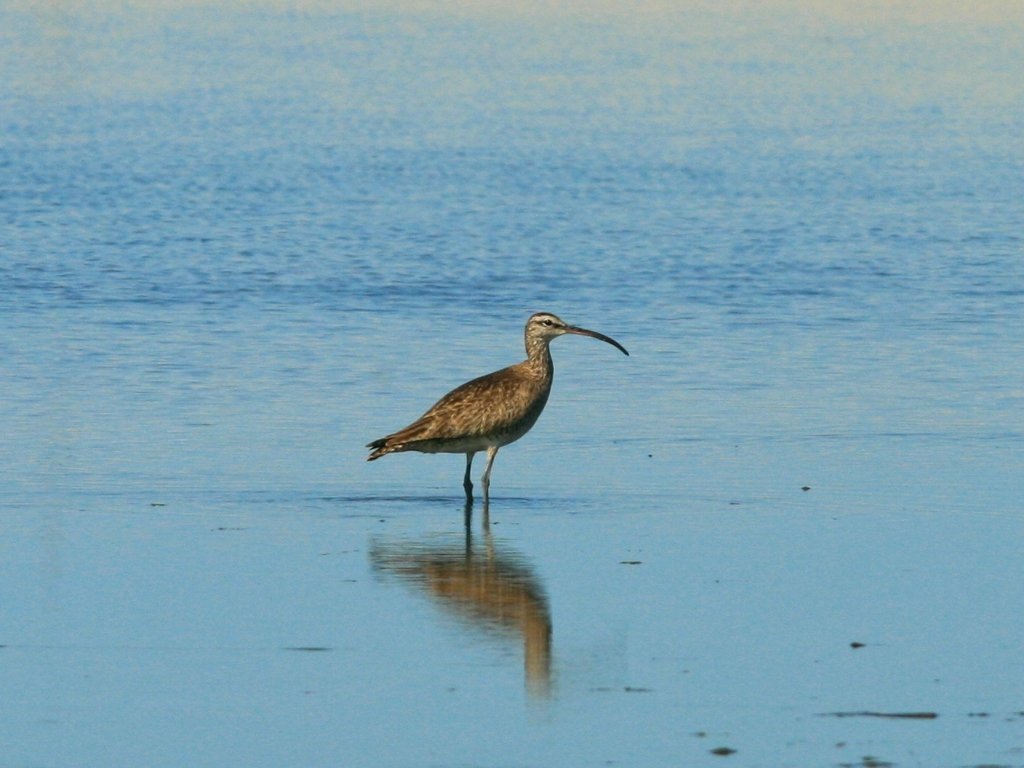How would you describe the clarity of the image?
A. Low
B. Excellent
C. Average
D. High The clarity of the image can be described as high. The subject, which appears to be a bird, is in focus with good resolution, allowing for clear visibility of details like its feather patterns and the reflection on the water. The colors are well-defined against the background without any noticeable blurring or distortion. 